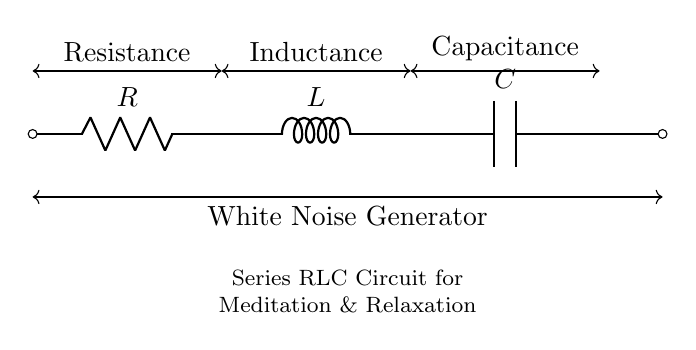What components are in the circuit? The circuit includes a resistor (R), an inductor (L), and a capacitor (C). These components are clearly labeled on the diagram.
Answer: Resistor, Inductor, Capacitor What is the role of the resistor in this circuit? The resistor limits the current flow within the series RLC circuit, affecting the overall resistance, which impacts how the circuit generates white noise.
Answer: Current limitation What does the arrow indicate in the circuit? The arrow in the diagram indicates the direction of current flow; a common convention for electrical schematics that helps visualize the flow of electricity.
Answer: Current flow direction How does the inductor affect the circuit behavior? The inductor stores energy in a magnetic field when current flows through it, which affects the impedance and phase of the circuit, leading to resonance when paired with the capacitor.
Answer: Resonance effect What happens when the values of R, L, and C are increased? Increasing the resistor value will lower the current and adjust the damping, while increasing the inductor and capacitor values affects the resonance frequency, possibly lowering it; together, they modify circuit response.
Answer: Modify circuit response 